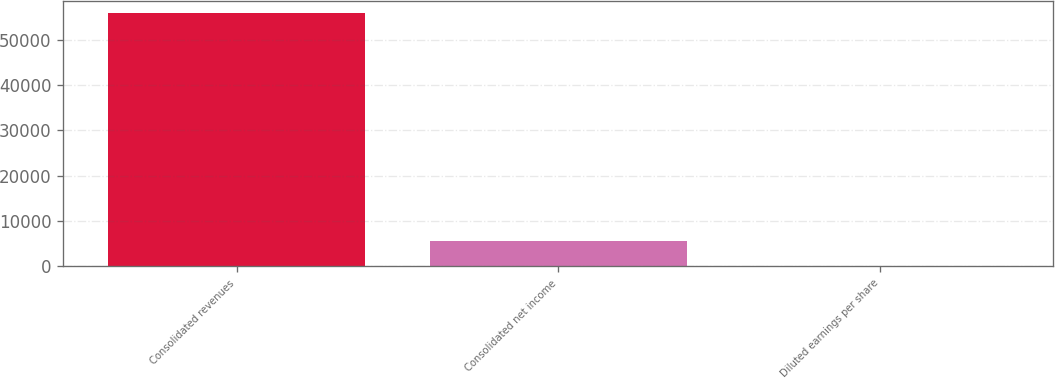Convert chart. <chart><loc_0><loc_0><loc_500><loc_500><bar_chart><fcel>Consolidated revenues<fcel>Consolidated net income<fcel>Diluted earnings per share<nl><fcel>55862<fcel>5588.2<fcel>2.22<nl></chart> 